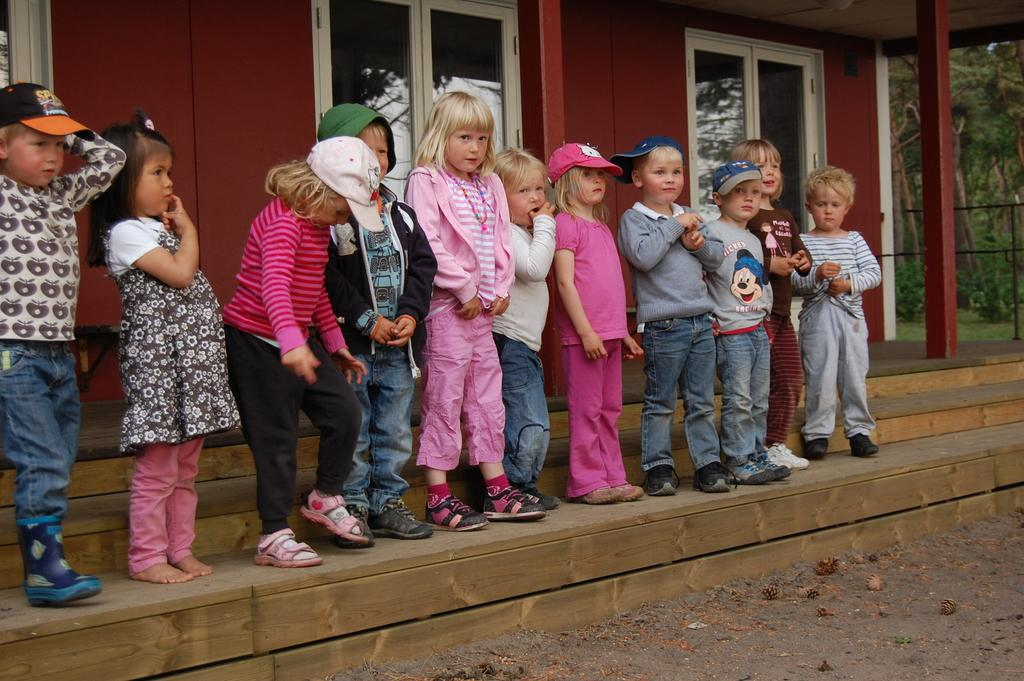What type of windows does the building have? The building has glass windows. What can be seen in front of the building? Kids are standing in front of the building. What is the color of the building's wall? The wall of the building is maroon in color. What type of vegetation is visible in the image? There are trees and plants visible in the image. What shape is the marble that the kids are playing with in the image? There is no marble present in the image, and the kids are not shown playing with any objects. 